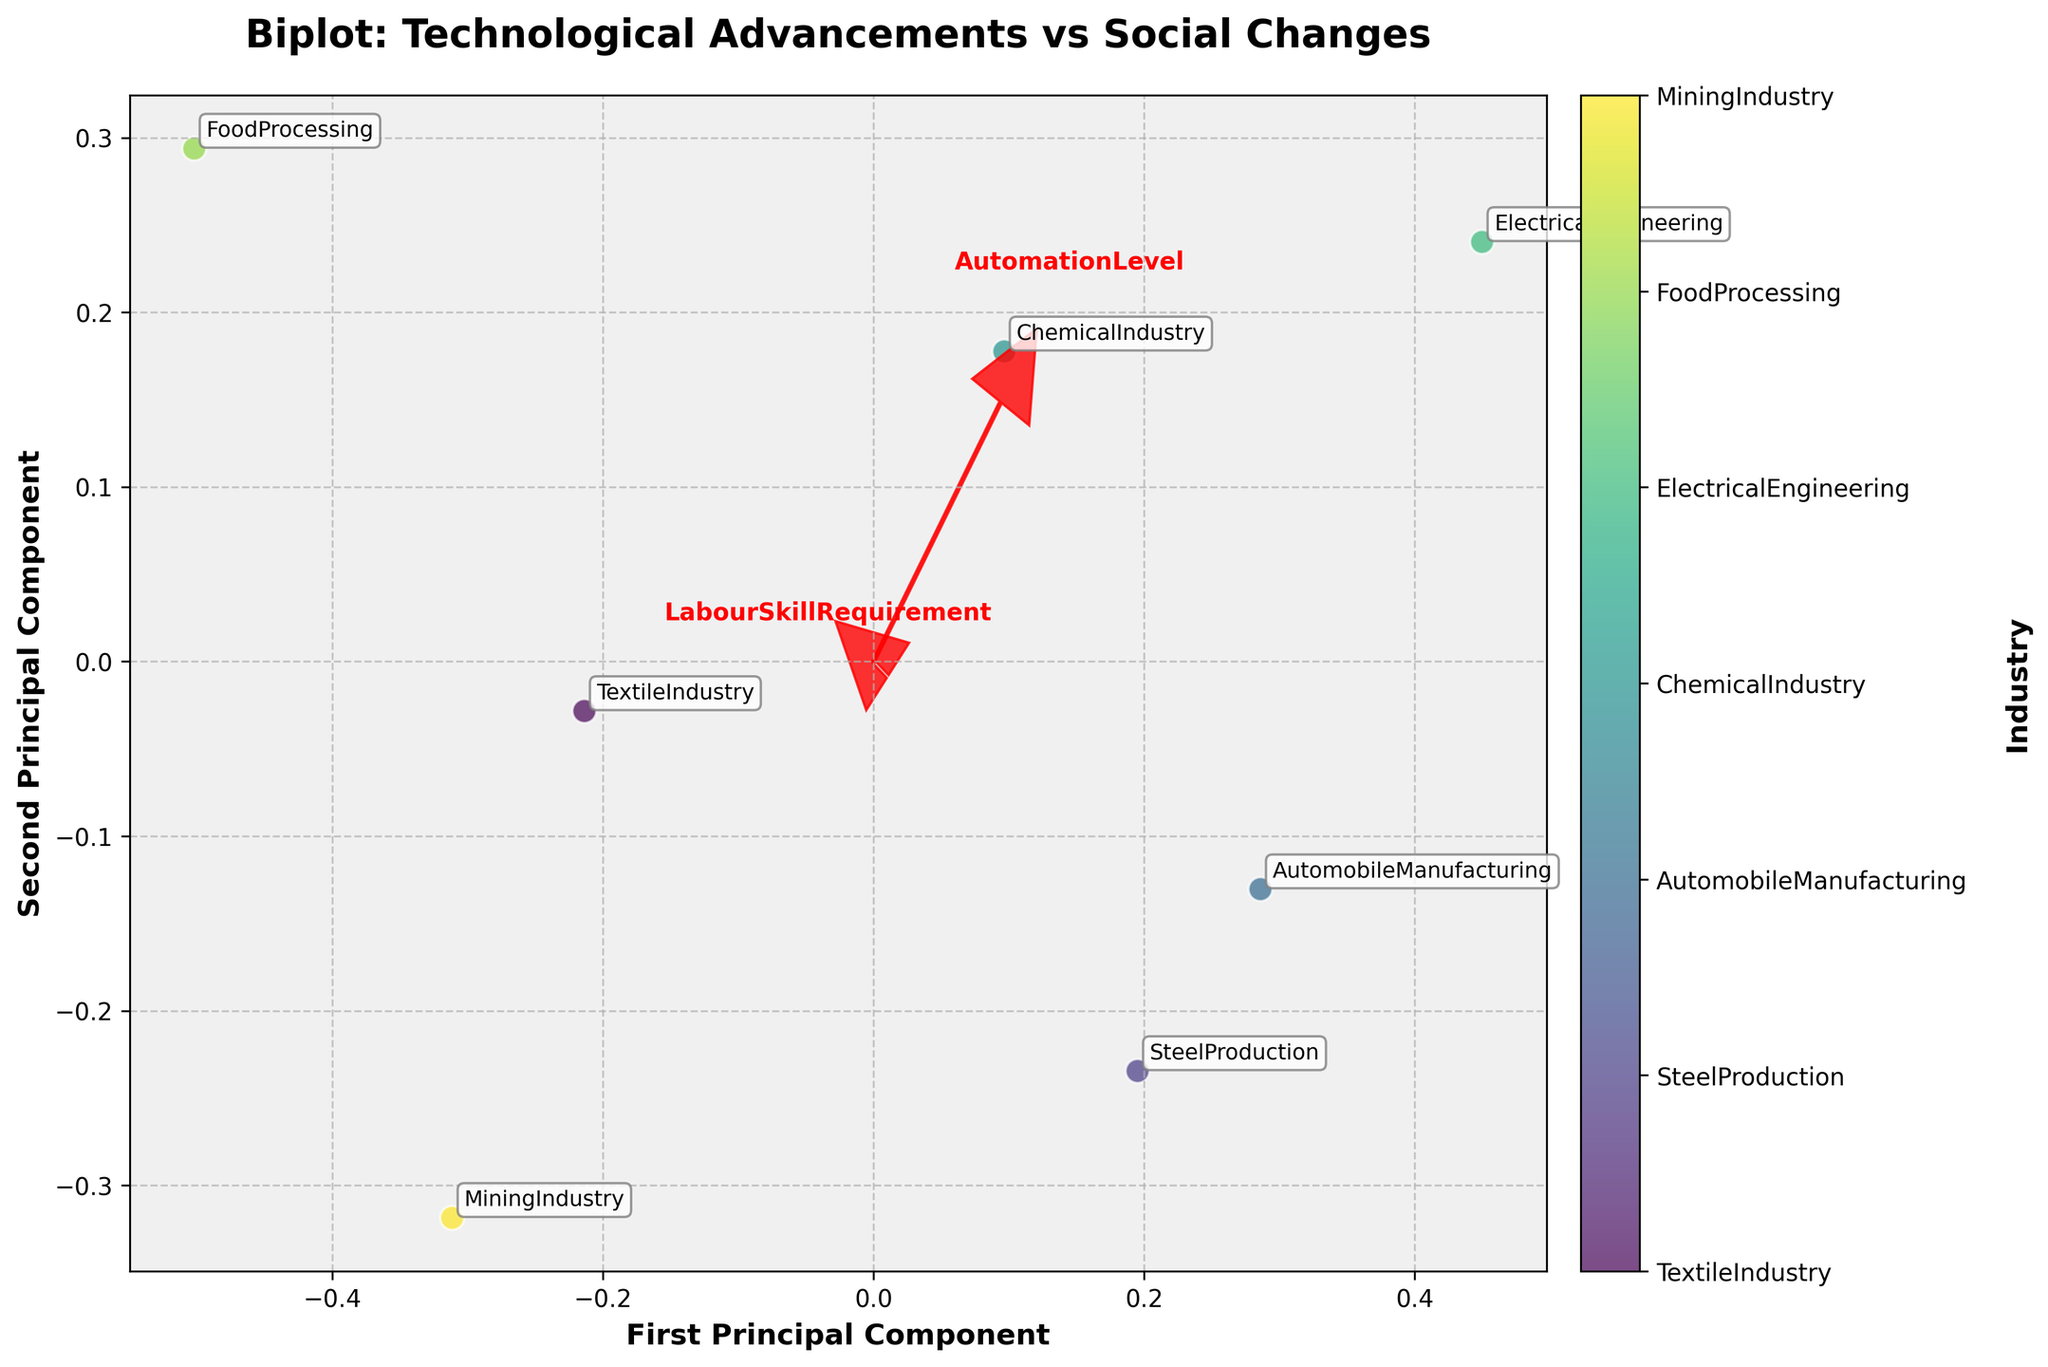What is the title of the figure? The title is the text displayed at the top of the figure. It describes the content or purpose of the figure.
Answer: Biplot: Technological Advancements vs Social Changes How many data points are represented in the plot? Count the number of distinct points in the scatter plot. Each point corresponds to an industry.
Answer: 7 Which two industries are closest to each other in the plot? Look for the two points that are nearest to each other in terms of their positions on the plot.
Answer: TextileIndustry and MiningIndustry Which industry shows the highest value on the first principal component axis? Identify the industry whose data point is furthest along the positive x-axis.
Answer: AutomobileManufacturing What direction does the eigenvector representing 'LabourSkillRequirement' point towards? Observe the red eigenvector arrow labeled 'LabourSkillRequirement' and note its direction.
Answer: Towards the top-right Which industry has the lowest value on the second principal component axis? Find the industry whose data point is furthest along the negative y-axis.
Answer: MiningIndustry What can you infer about the relationship between UrbanMigration and MiddleClassGrowth based on the eigenvectors? Look at the angles between the red eigenvector arrows for 'UrbanMigration' and 'MiddleClassGrowth' to determine their relationship. If they are close to parallel, it suggests a positive correlation.
Answer: Positive correlation Is the MiddleClassGrowth more closely associated with 'AutomobileManufacturing' or 'FoodProcessing'? Compare the positions of the eigenvector for 'MiddleClassGrowth' with the points representing 'AutomobileManufacturing' and 'FoodProcessing'. The closer the point to the eigenvector, the stronger the association.
Answer: AutomobileManufacturing Which factors appear to contribute most to the variance explained by the second principal component? Look at the length and direction of the eigenvectors along the second principal component (y-axis). The longer and more aligned the vectors, the more they contribute.
Answer: LabourSkillRequirement and FemaleWorkforceParticipation 